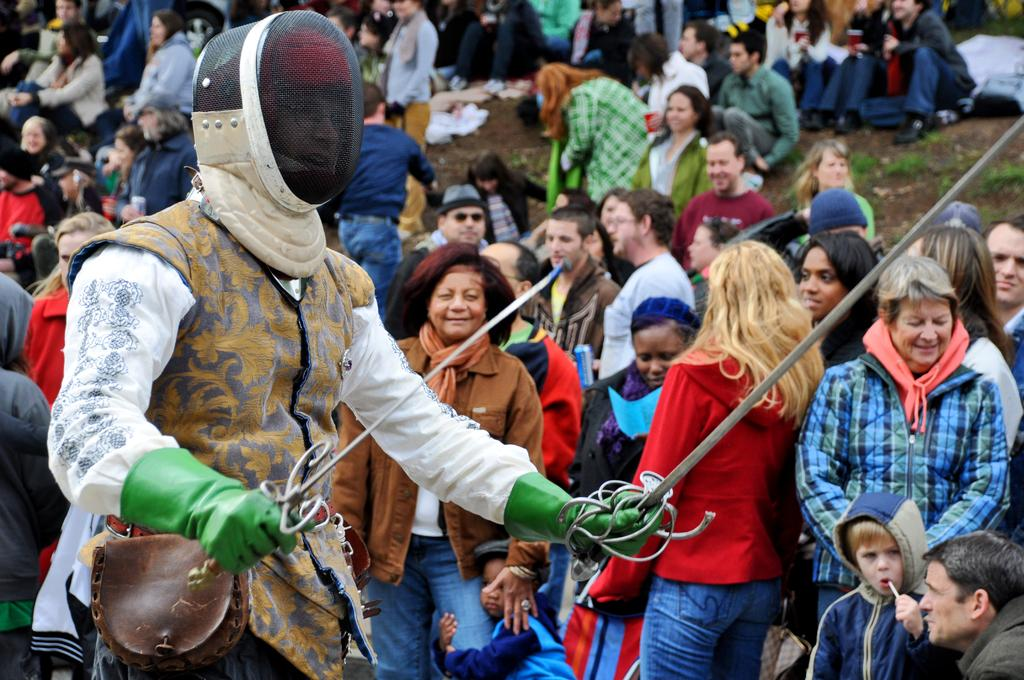How many people are in the image? There are people in the image. Can you describe the attire of one of the people? One person is wearing a helmet. What is the person wearing a helmet holding? The person wearing a helmet is holding weapons. What type of faucet can be seen in the image? There is no faucet present in the image. What scientific discovery is being made by the person wearing a helmet? The image does not depict any scientific discovery being made; it shows a person wearing a helmet holding weapons. 